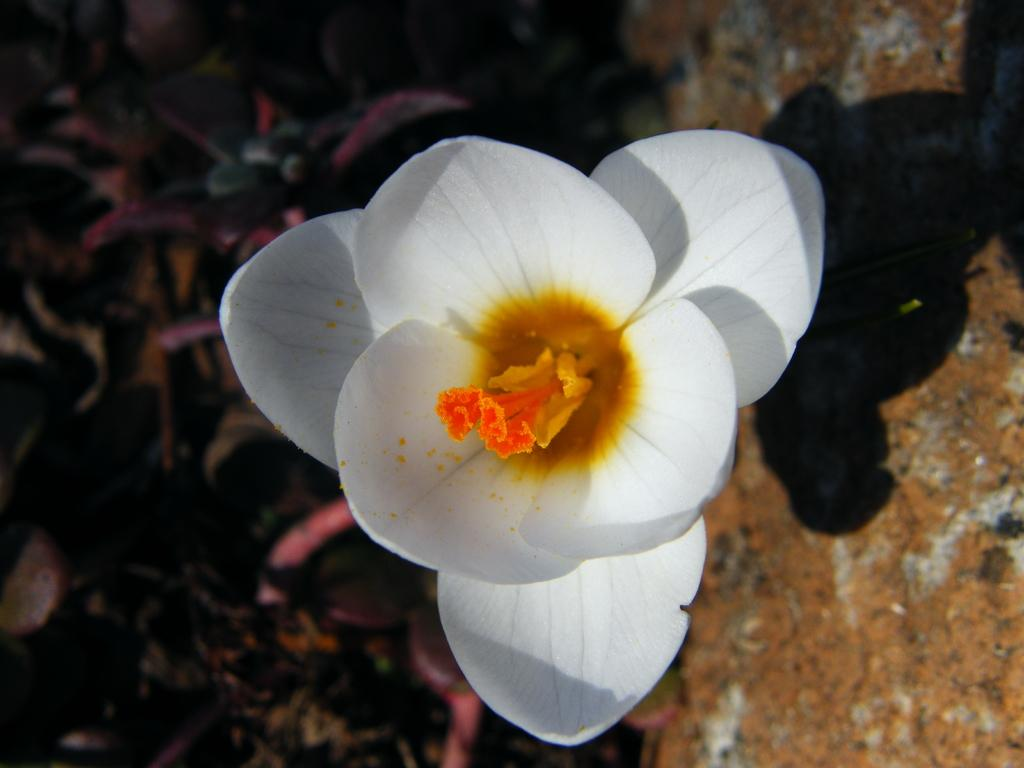What can be seen in the image that represents a living organism? There is a flower in the image. What is visible on the ground in the image? There is a shadow on the ground in the image. What is located on the left side of the image? There is a plant on the left side of the image, but it is not clear. What type of error can be seen in the image? There is no error present in the image. Can you describe the reaction of the flower to the sunlight? The image does not show the flower's reaction to sunlight, as it is a still image and does not capture movement or reactions. 